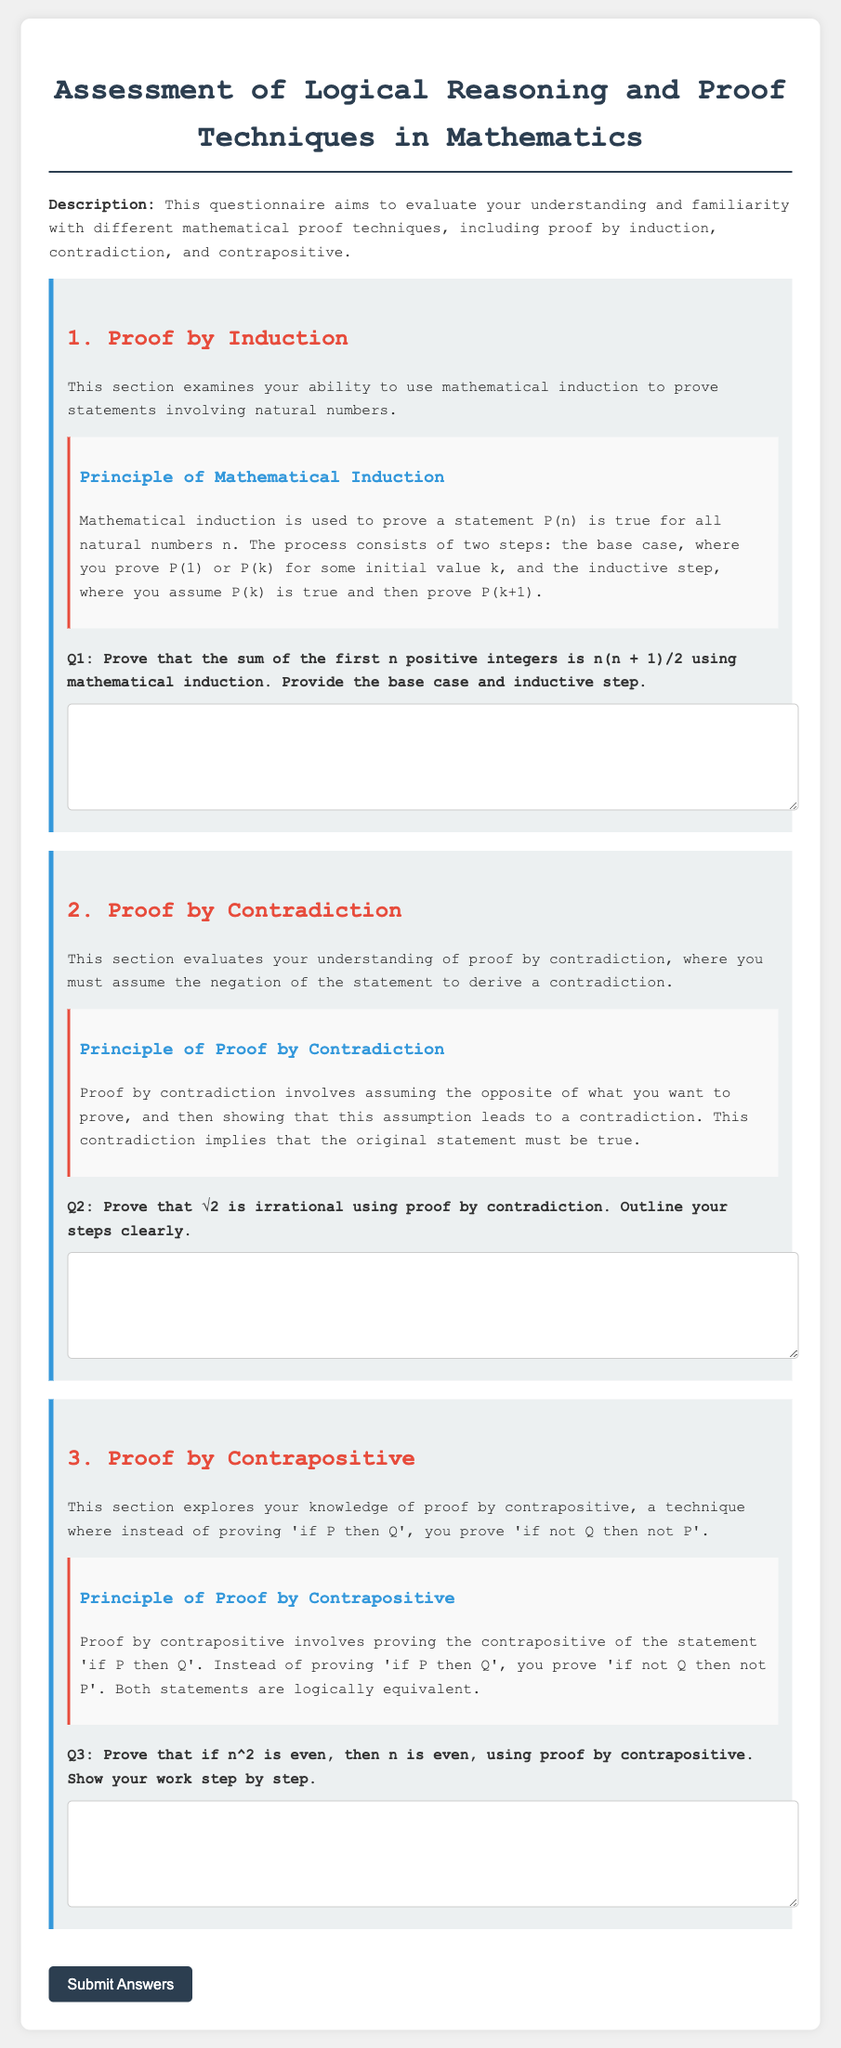What is the title of the document? The title is specified in the document's head section, presenting the focus of the content.
Answer: Assessment of Logical Reasoning and Proof Techniques in Mathematics What are the three proof techniques mentioned? The document outlines three distinct methods of proof which are crucial for logical reasoning in mathematics.
Answer: Proof by Induction, Proof by Contradiction, Proof by Contrapositive What does the base case in proof by induction prove? The document explains the necessity of the base case step in the proof by induction method.
Answer: P(1) or P(k) What is the result of the proof by induction question? The specific mathematical statement to be proven through induction is outlined clearly in the document.
Answer: n(n + 1)/2 What is proven using proof by contradiction in the questionnaire? The document provides a specific example that illustrates the application of this proof technique.
Answer: √2 is irrational What is the main focus of the proof by contrapositive section? The document highlights the technique specific to proving statements through their contrapositive forms.
Answer: Proving 'if not Q then not P' How many topics are included in the questionnaire? The document outlines the number of distinct sections that relate to different proof techniques, each addressing a teaching aspect.
Answer: Three What is the main purpose of this document? The introduction section clarifies the document's aim regarding the evaluation of understanding in mathematical proofs.
Answer: To evaluate understanding and familiarity with different mathematical proof techniques What should the user do after answering the questions? The document includes a call to action that describes what happens after the questionnaire is filled out.
Answer: Submit Answers 